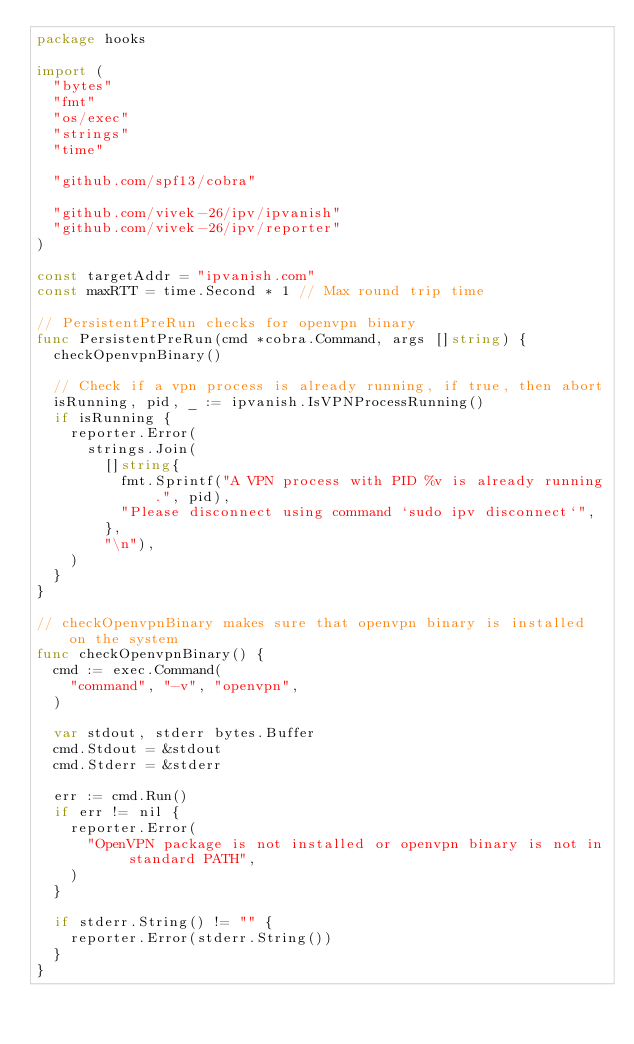<code> <loc_0><loc_0><loc_500><loc_500><_Go_>package hooks

import (
	"bytes"
	"fmt"
	"os/exec"
	"strings"
	"time"

	"github.com/spf13/cobra"

	"github.com/vivek-26/ipv/ipvanish"
	"github.com/vivek-26/ipv/reporter"
)

const targetAddr = "ipvanish.com"
const maxRTT = time.Second * 1 // Max round trip time

// PersistentPreRun checks for openvpn binary
func PersistentPreRun(cmd *cobra.Command, args []string) {
	checkOpenvpnBinary()

	// Check if a vpn process is already running, if true, then abort
	isRunning, pid, _ := ipvanish.IsVPNProcessRunning()
	if isRunning {
		reporter.Error(
			strings.Join(
				[]string{
					fmt.Sprintf("A VPN process with PID %v is already running.", pid),
					"Please disconnect using command `sudo ipv disconnect`",
				},
				"\n"),
		)
	}
}

// checkOpenvpnBinary makes sure that openvpn binary is installed on the system
func checkOpenvpnBinary() {
	cmd := exec.Command(
		"command", "-v", "openvpn",
	)

	var stdout, stderr bytes.Buffer
	cmd.Stdout = &stdout
	cmd.Stderr = &stderr

	err := cmd.Run()
	if err != nil {
		reporter.Error(
			"OpenVPN package is not installed or openvpn binary is not in standard PATH",
		)
	}

	if stderr.String() != "" {
		reporter.Error(stderr.String())
	}
}
</code> 